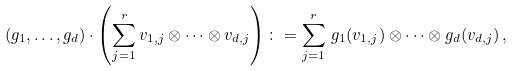<formula> <loc_0><loc_0><loc_500><loc_500>( g _ { 1 } , \dots , g _ { d } ) \cdot \left ( \sum _ { j = 1 } ^ { r } v _ { 1 , j } \otimes \cdots \otimes v _ { d , j } \right ) \colon = \sum _ { j = 1 } ^ { r } \, g _ { 1 } ( v _ { 1 , j } ) \otimes \cdots \otimes g _ { d } ( v _ { d , j } ) \, ,</formula> 